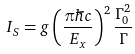Convert formula to latex. <formula><loc_0><loc_0><loc_500><loc_500>I _ { S } = g \left ( \frac { \pi \hbar { c } } { E _ { x } } \right ) ^ { 2 } \frac { \Gamma ^ { 2 } _ { 0 } } { \Gamma }</formula> 